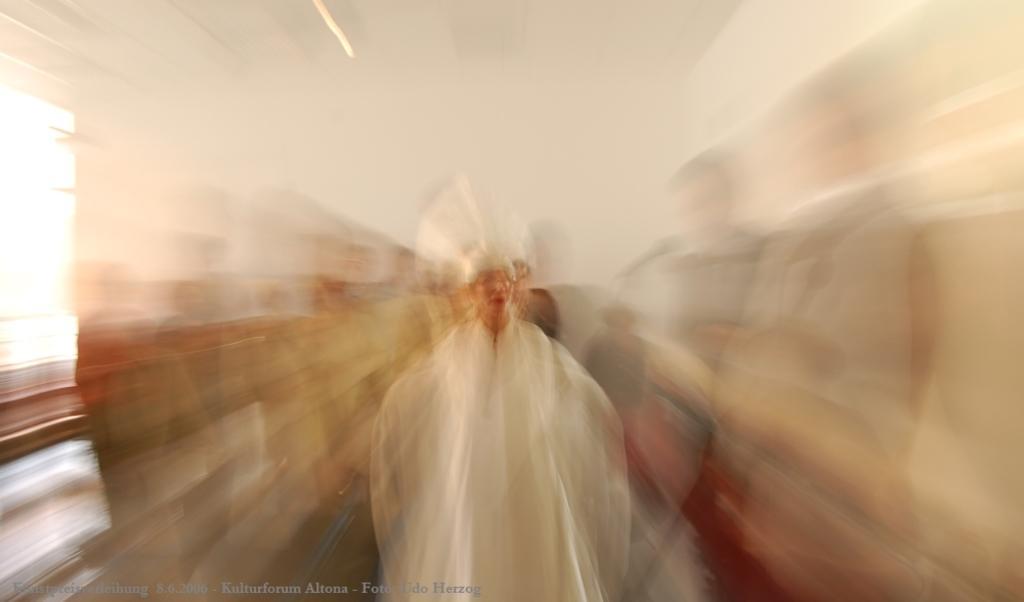Describe this image in one or two sentences. In this we can see a blurry picture, here we can find few people, in the bottom left hand corner we can see some text. 